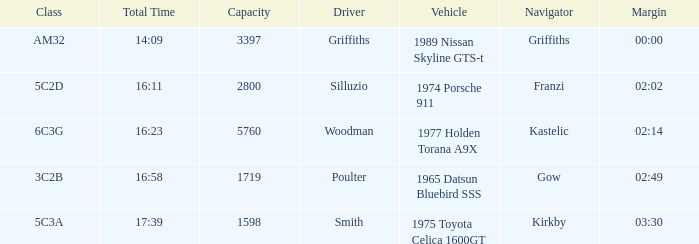Which vehicle has a class 6c3g? 1977 Holden Torana A9X. 